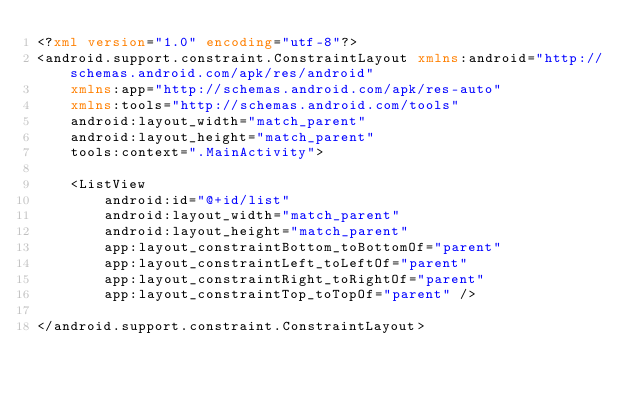<code> <loc_0><loc_0><loc_500><loc_500><_XML_><?xml version="1.0" encoding="utf-8"?>
<android.support.constraint.ConstraintLayout xmlns:android="http://schemas.android.com/apk/res/android"
    xmlns:app="http://schemas.android.com/apk/res-auto"
    xmlns:tools="http://schemas.android.com/tools"
    android:layout_width="match_parent"
    android:layout_height="match_parent"
    tools:context=".MainActivity">

    <ListView
        android:id="@+id/list"
        android:layout_width="match_parent"
        android:layout_height="match_parent"
        app:layout_constraintBottom_toBottomOf="parent"
        app:layout_constraintLeft_toLeftOf="parent"
        app:layout_constraintRight_toRightOf="parent"
        app:layout_constraintTop_toTopOf="parent" />

</android.support.constraint.ConstraintLayout></code> 